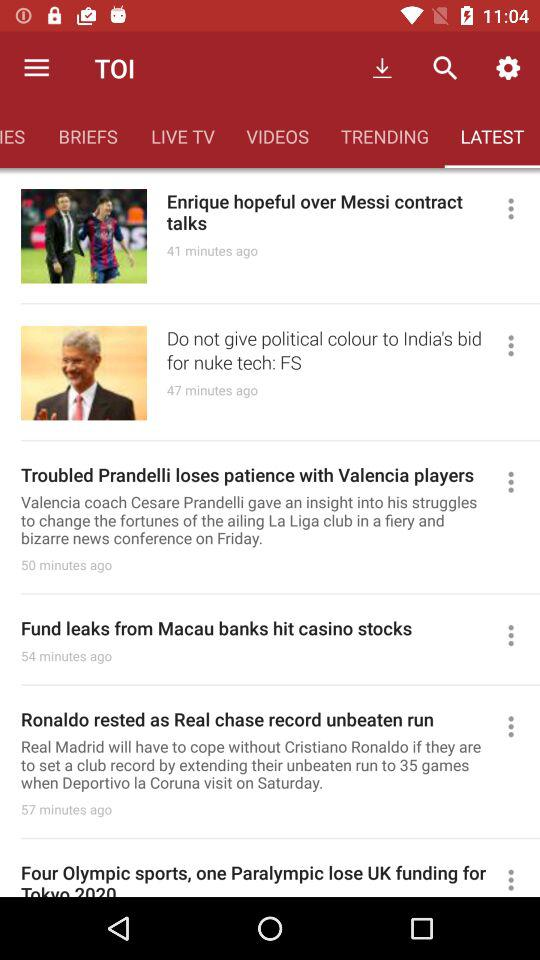How many more minutes ago was the latest news item published than the oldest one?
Answer the question using a single word or phrase. 16 